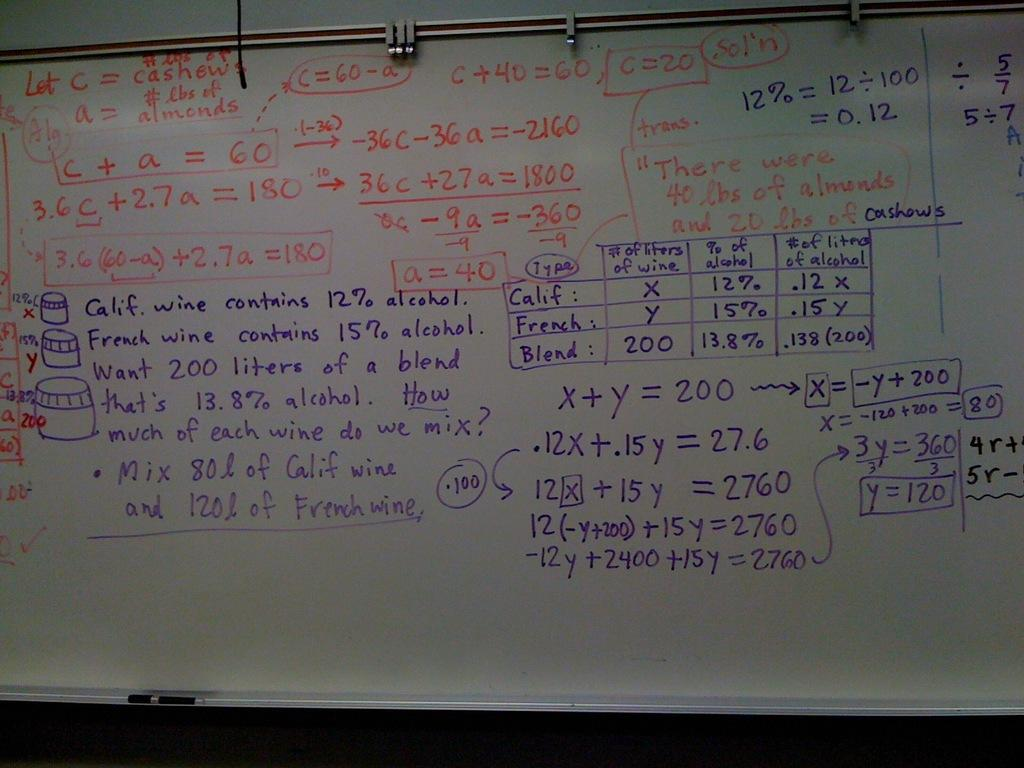<image>
Provide a brief description of the given image. A white board with equations such as c+a=60. 